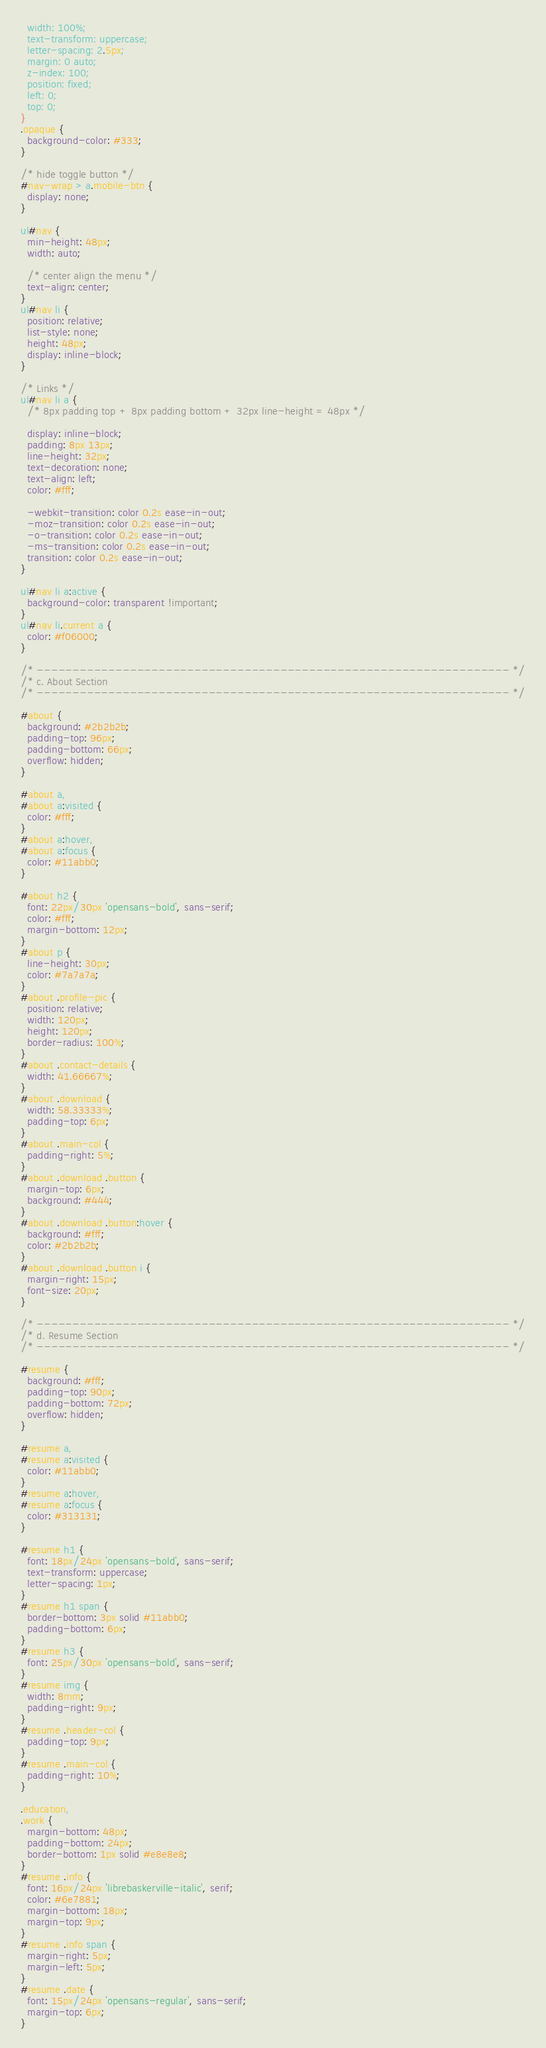Convert code to text. <code><loc_0><loc_0><loc_500><loc_500><_CSS_>  width: 100%;
  text-transform: uppercase;
  letter-spacing: 2.5px;
  margin: 0 auto;
  z-index: 100;
  position: fixed;
  left: 0;
  top: 0;
}
.opaque {
  background-color: #333;
}

/* hide toggle button */
#nav-wrap > a.mobile-btn {
  display: none;
}

ul#nav {
  min-height: 48px;
  width: auto;

  /* center align the menu */
  text-align: center;
}
ul#nav li {
  position: relative;
  list-style: none;
  height: 48px;
  display: inline-block;
}

/* Links */
ul#nav li a {
  /* 8px padding top + 8px padding bottom + 32px line-height = 48px */

  display: inline-block;
  padding: 8px 13px;
  line-height: 32px;
  text-decoration: none;
  text-align: left;
  color: #fff;

  -webkit-transition: color 0.2s ease-in-out;
  -moz-transition: color 0.2s ease-in-out;
  -o-transition: color 0.2s ease-in-out;
  -ms-transition: color 0.2s ease-in-out;
  transition: color 0.2s ease-in-out;
}

ul#nav li a:active {
  background-color: transparent !important;
}
ul#nav li.current a {
  color: #f06000;
}

/* ------------------------------------------------------------------ */
/* c. About Section
/* ------------------------------------------------------------------ */

#about {
  background: #2b2b2b;
  padding-top: 96px;
  padding-bottom: 66px;
  overflow: hidden;
}

#about a,
#about a:visited {
  color: #fff;
}
#about a:hover,
#about a:focus {
  color: #11abb0;
}

#about h2 {
  font: 22px/30px 'opensans-bold', sans-serif;
  color: #fff;
  margin-bottom: 12px;
}
#about p {
  line-height: 30px;
  color: #7a7a7a;
}
#about .profile-pic {
  position: relative;
  width: 120px;
  height: 120px;
  border-radius: 100%;
}
#about .contact-details {
  width: 41.66667%;
}
#about .download {
  width: 58.33333%;
  padding-top: 6px;
}
#about .main-col {
  padding-right: 5%;
}
#about .download .button {
  margin-top: 6px;
  background: #444;
}
#about .download .button:hover {
  background: #fff;
  color: #2b2b2b;
}
#about .download .button i {
  margin-right: 15px;
  font-size: 20px;
}

/* ------------------------------------------------------------------ */
/* d. Resume Section
/* ------------------------------------------------------------------ */

#resume {
  background: #fff;
  padding-top: 90px;
  padding-bottom: 72px;
  overflow: hidden;
}

#resume a,
#resume a:visited {
  color: #11abb0;
}
#resume a:hover,
#resume a:focus {
  color: #313131;
}

#resume h1 {
  font: 18px/24px 'opensans-bold', sans-serif;
  text-transform: uppercase;
  letter-spacing: 1px;
}
#resume h1 span {
  border-bottom: 3px solid #11abb0;
  padding-bottom: 6px;
}
#resume h3 {
  font: 25px/30px 'opensans-bold', sans-serif;
}
#resume img {
  width: 8mm;
  padding-right: 9px;
}
#resume .header-col {
  padding-top: 9px;
}
#resume .main-col {
  padding-right: 10%;
}

.education,
.work {
  margin-bottom: 48px;
  padding-bottom: 24px;
  border-bottom: 1px solid #e8e8e8;
}
#resume .info {
  font: 16px/24px 'librebaskerville-italic', serif;
  color: #6e7881;
  margin-bottom: 18px;
  margin-top: 9px;
}
#resume .info span {
  margin-right: 5px;
  margin-left: 5px;
}
#resume .date {
  font: 15px/24px 'opensans-regular', sans-serif;
  margin-top: 6px;
}
</code> 